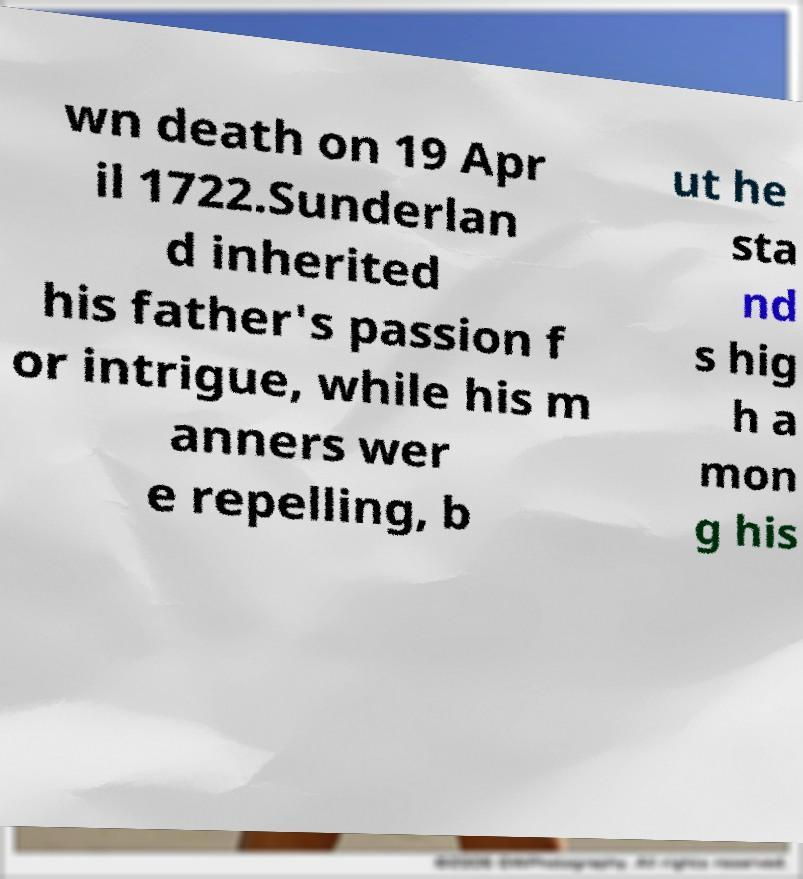Could you assist in decoding the text presented in this image and type it out clearly? wn death on 19 Apr il 1722.Sunderlan d inherited his father's passion f or intrigue, while his m anners wer e repelling, b ut he sta nd s hig h a mon g his 